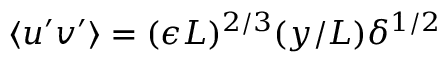Convert formula to latex. <formula><loc_0><loc_0><loc_500><loc_500>\langle u ^ { \prime } v ^ { \prime } \rangle = ( \epsilon L ) ^ { 2 / 3 } ( y / L ) \delta ^ { 1 / 2 }</formula> 